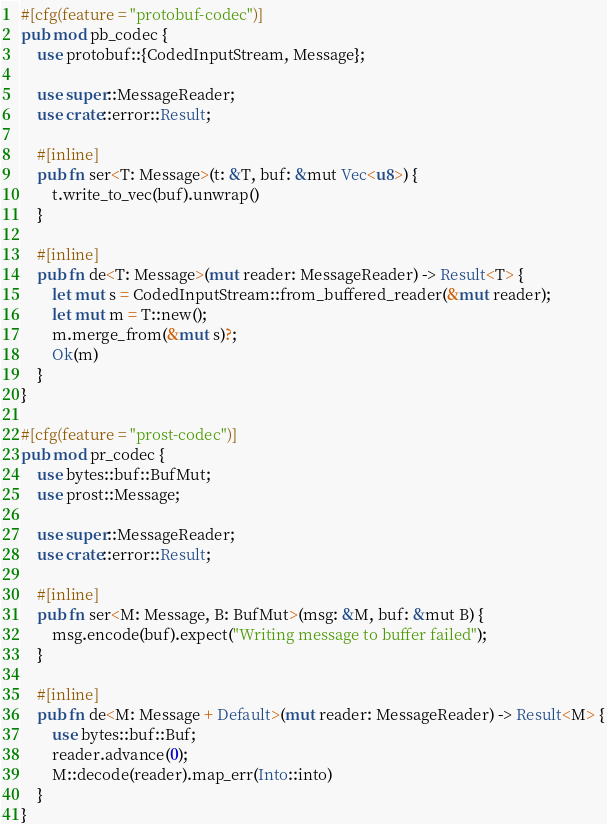Convert code to text. <code><loc_0><loc_0><loc_500><loc_500><_Rust_>#[cfg(feature = "protobuf-codec")]
pub mod pb_codec {
    use protobuf::{CodedInputStream, Message};

    use super::MessageReader;
    use crate::error::Result;

    #[inline]
    pub fn ser<T: Message>(t: &T, buf: &mut Vec<u8>) {
        t.write_to_vec(buf).unwrap()
    }

    #[inline]
    pub fn de<T: Message>(mut reader: MessageReader) -> Result<T> {
        let mut s = CodedInputStream::from_buffered_reader(&mut reader);
        let mut m = T::new();
        m.merge_from(&mut s)?;
        Ok(m)
    }
}

#[cfg(feature = "prost-codec")]
pub mod pr_codec {
    use bytes::buf::BufMut;
    use prost::Message;

    use super::MessageReader;
    use crate::error::Result;

    #[inline]
    pub fn ser<M: Message, B: BufMut>(msg: &M, buf: &mut B) {
        msg.encode(buf).expect("Writing message to buffer failed");
    }

    #[inline]
    pub fn de<M: Message + Default>(mut reader: MessageReader) -> Result<M> {
        use bytes::buf::Buf;
        reader.advance(0);
        M::decode(reader).map_err(Into::into)
    }
}
</code> 